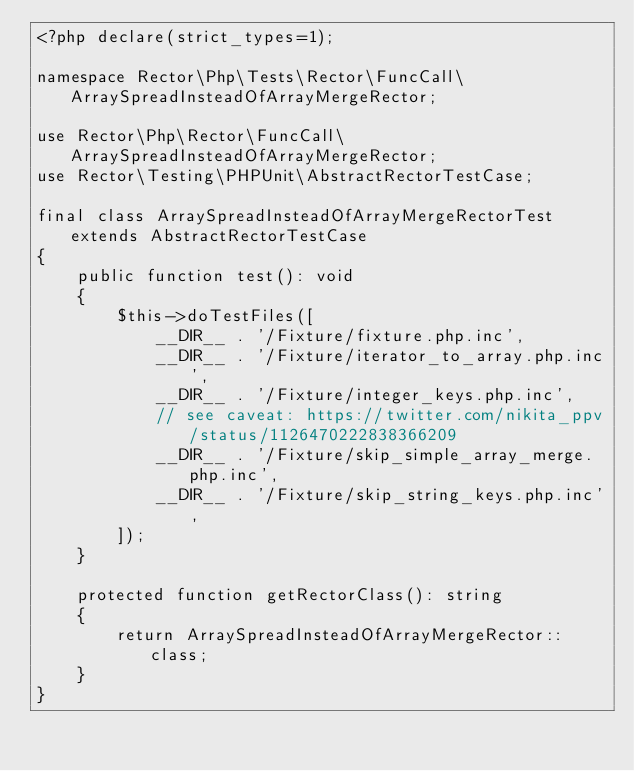<code> <loc_0><loc_0><loc_500><loc_500><_PHP_><?php declare(strict_types=1);

namespace Rector\Php\Tests\Rector\FuncCall\ArraySpreadInsteadOfArrayMergeRector;

use Rector\Php\Rector\FuncCall\ArraySpreadInsteadOfArrayMergeRector;
use Rector\Testing\PHPUnit\AbstractRectorTestCase;

final class ArraySpreadInsteadOfArrayMergeRectorTest extends AbstractRectorTestCase
{
    public function test(): void
    {
        $this->doTestFiles([
            __DIR__ . '/Fixture/fixture.php.inc',
            __DIR__ . '/Fixture/iterator_to_array.php.inc',
            __DIR__ . '/Fixture/integer_keys.php.inc',
            // see caveat: https://twitter.com/nikita_ppv/status/1126470222838366209
            __DIR__ . '/Fixture/skip_simple_array_merge.php.inc',
            __DIR__ . '/Fixture/skip_string_keys.php.inc',
        ]);
    }

    protected function getRectorClass(): string
    {
        return ArraySpreadInsteadOfArrayMergeRector::class;
    }
}
</code> 